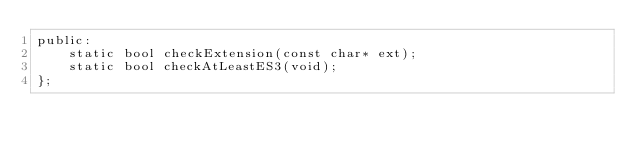<code> <loc_0><loc_0><loc_500><loc_500><_C_>public:
    static bool checkExtension(const char* ext);
    static bool checkAtLeastES3(void);
};
</code> 